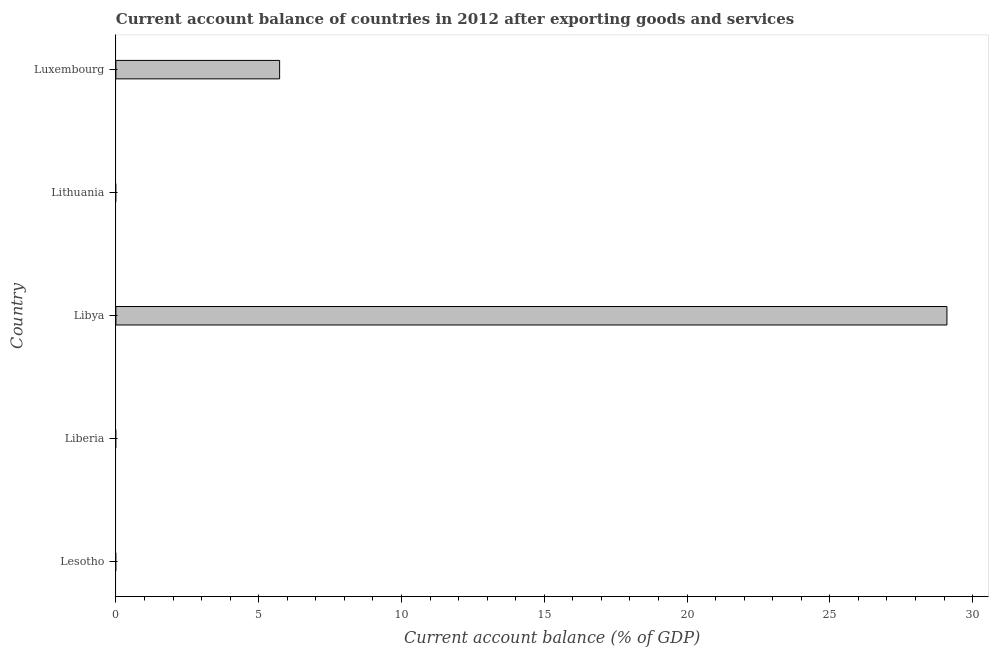Does the graph contain grids?
Your response must be concise. No. What is the title of the graph?
Make the answer very short. Current account balance of countries in 2012 after exporting goods and services. What is the label or title of the X-axis?
Your answer should be compact. Current account balance (% of GDP). What is the label or title of the Y-axis?
Give a very brief answer. Country. Across all countries, what is the maximum current account balance?
Offer a terse response. 29.1. In which country was the current account balance maximum?
Provide a succinct answer. Libya. What is the sum of the current account balance?
Give a very brief answer. 34.84. What is the difference between the current account balance in Libya and Luxembourg?
Ensure brevity in your answer.  23.37. What is the average current account balance per country?
Your response must be concise. 6.97. What is the median current account balance?
Offer a very short reply. 0. In how many countries, is the current account balance greater than 7 %?
Provide a short and direct response. 1. What is the difference between the highest and the lowest current account balance?
Provide a succinct answer. 29.1. In how many countries, is the current account balance greater than the average current account balance taken over all countries?
Offer a very short reply. 1. How many bars are there?
Give a very brief answer. 2. What is the difference between two consecutive major ticks on the X-axis?
Keep it short and to the point. 5. What is the Current account balance (% of GDP) of Lesotho?
Offer a terse response. 0. What is the Current account balance (% of GDP) of Libya?
Provide a short and direct response. 29.1. What is the Current account balance (% of GDP) in Luxembourg?
Provide a short and direct response. 5.73. What is the difference between the Current account balance (% of GDP) in Libya and Luxembourg?
Offer a terse response. 23.37. What is the ratio of the Current account balance (% of GDP) in Libya to that in Luxembourg?
Offer a very short reply. 5.08. 